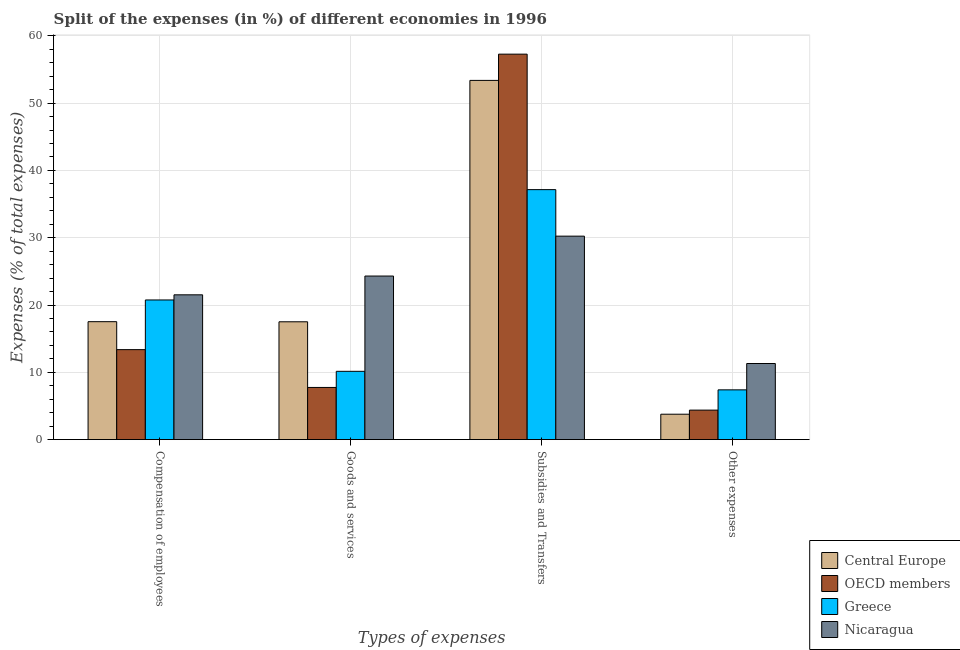How many different coloured bars are there?
Make the answer very short. 4. Are the number of bars on each tick of the X-axis equal?
Offer a terse response. Yes. How many bars are there on the 2nd tick from the left?
Offer a very short reply. 4. How many bars are there on the 3rd tick from the right?
Provide a short and direct response. 4. What is the label of the 4th group of bars from the left?
Your answer should be very brief. Other expenses. What is the percentage of amount spent on compensation of employees in OECD members?
Provide a succinct answer. 13.37. Across all countries, what is the maximum percentage of amount spent on compensation of employees?
Your answer should be compact. 21.51. Across all countries, what is the minimum percentage of amount spent on other expenses?
Your answer should be very brief. 3.77. In which country was the percentage of amount spent on goods and services maximum?
Offer a very short reply. Nicaragua. In which country was the percentage of amount spent on goods and services minimum?
Make the answer very short. OECD members. What is the total percentage of amount spent on other expenses in the graph?
Keep it short and to the point. 26.86. What is the difference between the percentage of amount spent on subsidies in Nicaragua and that in Central Europe?
Offer a very short reply. -23.14. What is the difference between the percentage of amount spent on subsidies in Nicaragua and the percentage of amount spent on compensation of employees in OECD members?
Provide a succinct answer. 16.87. What is the average percentage of amount spent on subsidies per country?
Make the answer very short. 44.51. What is the difference between the percentage of amount spent on other expenses and percentage of amount spent on goods and services in Greece?
Offer a very short reply. -2.75. In how many countries, is the percentage of amount spent on subsidies greater than 38 %?
Ensure brevity in your answer.  2. What is the ratio of the percentage of amount spent on subsidies in OECD members to that in Greece?
Keep it short and to the point. 1.54. What is the difference between the highest and the second highest percentage of amount spent on compensation of employees?
Give a very brief answer. 0.76. What is the difference between the highest and the lowest percentage of amount spent on goods and services?
Offer a terse response. 16.55. In how many countries, is the percentage of amount spent on goods and services greater than the average percentage of amount spent on goods and services taken over all countries?
Your answer should be very brief. 2. Is the sum of the percentage of amount spent on other expenses in OECD members and Nicaragua greater than the maximum percentage of amount spent on goods and services across all countries?
Offer a very short reply. No. What does the 3rd bar from the right in Compensation of employees represents?
Provide a short and direct response. OECD members. How many bars are there?
Ensure brevity in your answer.  16. Are all the bars in the graph horizontal?
Give a very brief answer. No. How many countries are there in the graph?
Offer a very short reply. 4. What is the difference between two consecutive major ticks on the Y-axis?
Your response must be concise. 10. Are the values on the major ticks of Y-axis written in scientific E-notation?
Your answer should be very brief. No. Does the graph contain grids?
Provide a succinct answer. Yes. Where does the legend appear in the graph?
Ensure brevity in your answer.  Bottom right. How are the legend labels stacked?
Your answer should be compact. Vertical. What is the title of the graph?
Offer a terse response. Split of the expenses (in %) of different economies in 1996. Does "Palau" appear as one of the legend labels in the graph?
Provide a short and direct response. No. What is the label or title of the X-axis?
Provide a short and direct response. Types of expenses. What is the label or title of the Y-axis?
Give a very brief answer. Expenses (% of total expenses). What is the Expenses (% of total expenses) of Central Europe in Compensation of employees?
Your response must be concise. 17.52. What is the Expenses (% of total expenses) of OECD members in Compensation of employees?
Give a very brief answer. 13.37. What is the Expenses (% of total expenses) in Greece in Compensation of employees?
Keep it short and to the point. 20.75. What is the Expenses (% of total expenses) of Nicaragua in Compensation of employees?
Give a very brief answer. 21.51. What is the Expenses (% of total expenses) in Central Europe in Goods and services?
Your answer should be very brief. 17.51. What is the Expenses (% of total expenses) of OECD members in Goods and services?
Offer a very short reply. 7.75. What is the Expenses (% of total expenses) of Greece in Goods and services?
Offer a terse response. 10.15. What is the Expenses (% of total expenses) of Nicaragua in Goods and services?
Provide a succinct answer. 24.31. What is the Expenses (% of total expenses) in Central Europe in Subsidies and Transfers?
Your response must be concise. 53.38. What is the Expenses (% of total expenses) of OECD members in Subsidies and Transfers?
Provide a succinct answer. 57.28. What is the Expenses (% of total expenses) of Greece in Subsidies and Transfers?
Give a very brief answer. 37.15. What is the Expenses (% of total expenses) of Nicaragua in Subsidies and Transfers?
Provide a succinct answer. 30.23. What is the Expenses (% of total expenses) of Central Europe in Other expenses?
Your answer should be compact. 3.77. What is the Expenses (% of total expenses) in OECD members in Other expenses?
Your response must be concise. 4.38. What is the Expenses (% of total expenses) of Greece in Other expenses?
Make the answer very short. 7.39. What is the Expenses (% of total expenses) in Nicaragua in Other expenses?
Provide a succinct answer. 11.31. Across all Types of expenses, what is the maximum Expenses (% of total expenses) in Central Europe?
Keep it short and to the point. 53.38. Across all Types of expenses, what is the maximum Expenses (% of total expenses) in OECD members?
Offer a very short reply. 57.28. Across all Types of expenses, what is the maximum Expenses (% of total expenses) of Greece?
Give a very brief answer. 37.15. Across all Types of expenses, what is the maximum Expenses (% of total expenses) in Nicaragua?
Provide a succinct answer. 30.23. Across all Types of expenses, what is the minimum Expenses (% of total expenses) in Central Europe?
Make the answer very short. 3.77. Across all Types of expenses, what is the minimum Expenses (% of total expenses) in OECD members?
Offer a terse response. 4.38. Across all Types of expenses, what is the minimum Expenses (% of total expenses) in Greece?
Your answer should be very brief. 7.39. Across all Types of expenses, what is the minimum Expenses (% of total expenses) of Nicaragua?
Offer a terse response. 11.31. What is the total Expenses (% of total expenses) of Central Europe in the graph?
Provide a short and direct response. 92.18. What is the total Expenses (% of total expenses) of OECD members in the graph?
Ensure brevity in your answer.  82.78. What is the total Expenses (% of total expenses) in Greece in the graph?
Offer a very short reply. 75.44. What is the total Expenses (% of total expenses) of Nicaragua in the graph?
Give a very brief answer. 87.36. What is the difference between the Expenses (% of total expenses) of Central Europe in Compensation of employees and that in Goods and services?
Make the answer very short. 0.02. What is the difference between the Expenses (% of total expenses) in OECD members in Compensation of employees and that in Goods and services?
Provide a succinct answer. 5.62. What is the difference between the Expenses (% of total expenses) in Greece in Compensation of employees and that in Goods and services?
Your answer should be compact. 10.6. What is the difference between the Expenses (% of total expenses) in Nicaragua in Compensation of employees and that in Goods and services?
Give a very brief answer. -2.79. What is the difference between the Expenses (% of total expenses) in Central Europe in Compensation of employees and that in Subsidies and Transfers?
Make the answer very short. -35.85. What is the difference between the Expenses (% of total expenses) in OECD members in Compensation of employees and that in Subsidies and Transfers?
Offer a very short reply. -43.91. What is the difference between the Expenses (% of total expenses) in Greece in Compensation of employees and that in Subsidies and Transfers?
Your response must be concise. -16.39. What is the difference between the Expenses (% of total expenses) in Nicaragua in Compensation of employees and that in Subsidies and Transfers?
Your answer should be compact. -8.72. What is the difference between the Expenses (% of total expenses) in Central Europe in Compensation of employees and that in Other expenses?
Make the answer very short. 13.75. What is the difference between the Expenses (% of total expenses) in OECD members in Compensation of employees and that in Other expenses?
Offer a very short reply. 8.99. What is the difference between the Expenses (% of total expenses) of Greece in Compensation of employees and that in Other expenses?
Your answer should be very brief. 13.36. What is the difference between the Expenses (% of total expenses) of Nicaragua in Compensation of employees and that in Other expenses?
Ensure brevity in your answer.  10.21. What is the difference between the Expenses (% of total expenses) of Central Europe in Goods and services and that in Subsidies and Transfers?
Provide a succinct answer. -35.87. What is the difference between the Expenses (% of total expenses) of OECD members in Goods and services and that in Subsidies and Transfers?
Your response must be concise. -49.53. What is the difference between the Expenses (% of total expenses) of Greece in Goods and services and that in Subsidies and Transfers?
Keep it short and to the point. -27. What is the difference between the Expenses (% of total expenses) in Nicaragua in Goods and services and that in Subsidies and Transfers?
Offer a very short reply. -5.93. What is the difference between the Expenses (% of total expenses) of Central Europe in Goods and services and that in Other expenses?
Your response must be concise. 13.73. What is the difference between the Expenses (% of total expenses) of OECD members in Goods and services and that in Other expenses?
Make the answer very short. 3.37. What is the difference between the Expenses (% of total expenses) of Greece in Goods and services and that in Other expenses?
Your answer should be compact. 2.75. What is the difference between the Expenses (% of total expenses) in Nicaragua in Goods and services and that in Other expenses?
Provide a short and direct response. 13. What is the difference between the Expenses (% of total expenses) of Central Europe in Subsidies and Transfers and that in Other expenses?
Give a very brief answer. 49.61. What is the difference between the Expenses (% of total expenses) in OECD members in Subsidies and Transfers and that in Other expenses?
Make the answer very short. 52.9. What is the difference between the Expenses (% of total expenses) in Greece in Subsidies and Transfers and that in Other expenses?
Your response must be concise. 29.75. What is the difference between the Expenses (% of total expenses) in Nicaragua in Subsidies and Transfers and that in Other expenses?
Provide a succinct answer. 18.93. What is the difference between the Expenses (% of total expenses) in Central Europe in Compensation of employees and the Expenses (% of total expenses) in OECD members in Goods and services?
Provide a short and direct response. 9.77. What is the difference between the Expenses (% of total expenses) of Central Europe in Compensation of employees and the Expenses (% of total expenses) of Greece in Goods and services?
Provide a short and direct response. 7.38. What is the difference between the Expenses (% of total expenses) in Central Europe in Compensation of employees and the Expenses (% of total expenses) in Nicaragua in Goods and services?
Make the answer very short. -6.78. What is the difference between the Expenses (% of total expenses) in OECD members in Compensation of employees and the Expenses (% of total expenses) in Greece in Goods and services?
Keep it short and to the point. 3.22. What is the difference between the Expenses (% of total expenses) in OECD members in Compensation of employees and the Expenses (% of total expenses) in Nicaragua in Goods and services?
Offer a very short reply. -10.94. What is the difference between the Expenses (% of total expenses) of Greece in Compensation of employees and the Expenses (% of total expenses) of Nicaragua in Goods and services?
Your response must be concise. -3.55. What is the difference between the Expenses (% of total expenses) of Central Europe in Compensation of employees and the Expenses (% of total expenses) of OECD members in Subsidies and Transfers?
Provide a short and direct response. -39.75. What is the difference between the Expenses (% of total expenses) of Central Europe in Compensation of employees and the Expenses (% of total expenses) of Greece in Subsidies and Transfers?
Keep it short and to the point. -19.62. What is the difference between the Expenses (% of total expenses) of Central Europe in Compensation of employees and the Expenses (% of total expenses) of Nicaragua in Subsidies and Transfers?
Your response must be concise. -12.71. What is the difference between the Expenses (% of total expenses) in OECD members in Compensation of employees and the Expenses (% of total expenses) in Greece in Subsidies and Transfers?
Give a very brief answer. -23.78. What is the difference between the Expenses (% of total expenses) of OECD members in Compensation of employees and the Expenses (% of total expenses) of Nicaragua in Subsidies and Transfers?
Your answer should be very brief. -16.87. What is the difference between the Expenses (% of total expenses) of Greece in Compensation of employees and the Expenses (% of total expenses) of Nicaragua in Subsidies and Transfers?
Give a very brief answer. -9.48. What is the difference between the Expenses (% of total expenses) of Central Europe in Compensation of employees and the Expenses (% of total expenses) of OECD members in Other expenses?
Keep it short and to the point. 13.14. What is the difference between the Expenses (% of total expenses) in Central Europe in Compensation of employees and the Expenses (% of total expenses) in Greece in Other expenses?
Your answer should be compact. 10.13. What is the difference between the Expenses (% of total expenses) of Central Europe in Compensation of employees and the Expenses (% of total expenses) of Nicaragua in Other expenses?
Ensure brevity in your answer.  6.22. What is the difference between the Expenses (% of total expenses) of OECD members in Compensation of employees and the Expenses (% of total expenses) of Greece in Other expenses?
Your response must be concise. 5.98. What is the difference between the Expenses (% of total expenses) of OECD members in Compensation of employees and the Expenses (% of total expenses) of Nicaragua in Other expenses?
Your answer should be compact. 2.06. What is the difference between the Expenses (% of total expenses) in Greece in Compensation of employees and the Expenses (% of total expenses) in Nicaragua in Other expenses?
Your answer should be very brief. 9.44. What is the difference between the Expenses (% of total expenses) of Central Europe in Goods and services and the Expenses (% of total expenses) of OECD members in Subsidies and Transfers?
Make the answer very short. -39.77. What is the difference between the Expenses (% of total expenses) of Central Europe in Goods and services and the Expenses (% of total expenses) of Greece in Subsidies and Transfers?
Keep it short and to the point. -19.64. What is the difference between the Expenses (% of total expenses) in Central Europe in Goods and services and the Expenses (% of total expenses) in Nicaragua in Subsidies and Transfers?
Provide a short and direct response. -12.73. What is the difference between the Expenses (% of total expenses) in OECD members in Goods and services and the Expenses (% of total expenses) in Greece in Subsidies and Transfers?
Make the answer very short. -29.39. What is the difference between the Expenses (% of total expenses) of OECD members in Goods and services and the Expenses (% of total expenses) of Nicaragua in Subsidies and Transfers?
Provide a succinct answer. -22.48. What is the difference between the Expenses (% of total expenses) in Greece in Goods and services and the Expenses (% of total expenses) in Nicaragua in Subsidies and Transfers?
Your answer should be very brief. -20.09. What is the difference between the Expenses (% of total expenses) of Central Europe in Goods and services and the Expenses (% of total expenses) of OECD members in Other expenses?
Ensure brevity in your answer.  13.13. What is the difference between the Expenses (% of total expenses) of Central Europe in Goods and services and the Expenses (% of total expenses) of Greece in Other expenses?
Give a very brief answer. 10.11. What is the difference between the Expenses (% of total expenses) in Central Europe in Goods and services and the Expenses (% of total expenses) in Nicaragua in Other expenses?
Give a very brief answer. 6.2. What is the difference between the Expenses (% of total expenses) in OECD members in Goods and services and the Expenses (% of total expenses) in Greece in Other expenses?
Provide a succinct answer. 0.36. What is the difference between the Expenses (% of total expenses) in OECD members in Goods and services and the Expenses (% of total expenses) in Nicaragua in Other expenses?
Offer a terse response. -3.56. What is the difference between the Expenses (% of total expenses) of Greece in Goods and services and the Expenses (% of total expenses) of Nicaragua in Other expenses?
Offer a very short reply. -1.16. What is the difference between the Expenses (% of total expenses) in Central Europe in Subsidies and Transfers and the Expenses (% of total expenses) in OECD members in Other expenses?
Your answer should be very brief. 49. What is the difference between the Expenses (% of total expenses) in Central Europe in Subsidies and Transfers and the Expenses (% of total expenses) in Greece in Other expenses?
Ensure brevity in your answer.  45.99. What is the difference between the Expenses (% of total expenses) in Central Europe in Subsidies and Transfers and the Expenses (% of total expenses) in Nicaragua in Other expenses?
Your answer should be very brief. 42.07. What is the difference between the Expenses (% of total expenses) in OECD members in Subsidies and Transfers and the Expenses (% of total expenses) in Greece in Other expenses?
Provide a succinct answer. 49.89. What is the difference between the Expenses (% of total expenses) in OECD members in Subsidies and Transfers and the Expenses (% of total expenses) in Nicaragua in Other expenses?
Offer a very short reply. 45.97. What is the difference between the Expenses (% of total expenses) in Greece in Subsidies and Transfers and the Expenses (% of total expenses) in Nicaragua in Other expenses?
Give a very brief answer. 25.84. What is the average Expenses (% of total expenses) in Central Europe per Types of expenses?
Provide a succinct answer. 23.05. What is the average Expenses (% of total expenses) of OECD members per Types of expenses?
Ensure brevity in your answer.  20.7. What is the average Expenses (% of total expenses) of Greece per Types of expenses?
Provide a short and direct response. 18.86. What is the average Expenses (% of total expenses) in Nicaragua per Types of expenses?
Give a very brief answer. 21.84. What is the difference between the Expenses (% of total expenses) in Central Europe and Expenses (% of total expenses) in OECD members in Compensation of employees?
Your response must be concise. 4.16. What is the difference between the Expenses (% of total expenses) in Central Europe and Expenses (% of total expenses) in Greece in Compensation of employees?
Give a very brief answer. -3.23. What is the difference between the Expenses (% of total expenses) in Central Europe and Expenses (% of total expenses) in Nicaragua in Compensation of employees?
Offer a terse response. -3.99. What is the difference between the Expenses (% of total expenses) in OECD members and Expenses (% of total expenses) in Greece in Compensation of employees?
Provide a short and direct response. -7.38. What is the difference between the Expenses (% of total expenses) in OECD members and Expenses (% of total expenses) in Nicaragua in Compensation of employees?
Your response must be concise. -8.15. What is the difference between the Expenses (% of total expenses) in Greece and Expenses (% of total expenses) in Nicaragua in Compensation of employees?
Your response must be concise. -0.76. What is the difference between the Expenses (% of total expenses) of Central Europe and Expenses (% of total expenses) of OECD members in Goods and services?
Provide a succinct answer. 9.76. What is the difference between the Expenses (% of total expenses) of Central Europe and Expenses (% of total expenses) of Greece in Goods and services?
Offer a terse response. 7.36. What is the difference between the Expenses (% of total expenses) of Central Europe and Expenses (% of total expenses) of Nicaragua in Goods and services?
Ensure brevity in your answer.  -6.8. What is the difference between the Expenses (% of total expenses) of OECD members and Expenses (% of total expenses) of Greece in Goods and services?
Keep it short and to the point. -2.4. What is the difference between the Expenses (% of total expenses) of OECD members and Expenses (% of total expenses) of Nicaragua in Goods and services?
Your answer should be very brief. -16.55. What is the difference between the Expenses (% of total expenses) of Greece and Expenses (% of total expenses) of Nicaragua in Goods and services?
Ensure brevity in your answer.  -14.16. What is the difference between the Expenses (% of total expenses) of Central Europe and Expenses (% of total expenses) of OECD members in Subsidies and Transfers?
Offer a terse response. -3.9. What is the difference between the Expenses (% of total expenses) in Central Europe and Expenses (% of total expenses) in Greece in Subsidies and Transfers?
Ensure brevity in your answer.  16.23. What is the difference between the Expenses (% of total expenses) of Central Europe and Expenses (% of total expenses) of Nicaragua in Subsidies and Transfers?
Offer a terse response. 23.14. What is the difference between the Expenses (% of total expenses) in OECD members and Expenses (% of total expenses) in Greece in Subsidies and Transfers?
Offer a very short reply. 20.13. What is the difference between the Expenses (% of total expenses) of OECD members and Expenses (% of total expenses) of Nicaragua in Subsidies and Transfers?
Offer a very short reply. 27.04. What is the difference between the Expenses (% of total expenses) of Greece and Expenses (% of total expenses) of Nicaragua in Subsidies and Transfers?
Offer a terse response. 6.91. What is the difference between the Expenses (% of total expenses) in Central Europe and Expenses (% of total expenses) in OECD members in Other expenses?
Make the answer very short. -0.61. What is the difference between the Expenses (% of total expenses) in Central Europe and Expenses (% of total expenses) in Greece in Other expenses?
Your response must be concise. -3.62. What is the difference between the Expenses (% of total expenses) of Central Europe and Expenses (% of total expenses) of Nicaragua in Other expenses?
Provide a short and direct response. -7.54. What is the difference between the Expenses (% of total expenses) in OECD members and Expenses (% of total expenses) in Greece in Other expenses?
Make the answer very short. -3.01. What is the difference between the Expenses (% of total expenses) in OECD members and Expenses (% of total expenses) in Nicaragua in Other expenses?
Your answer should be compact. -6.93. What is the difference between the Expenses (% of total expenses) in Greece and Expenses (% of total expenses) in Nicaragua in Other expenses?
Your answer should be compact. -3.91. What is the ratio of the Expenses (% of total expenses) of OECD members in Compensation of employees to that in Goods and services?
Offer a terse response. 1.72. What is the ratio of the Expenses (% of total expenses) in Greece in Compensation of employees to that in Goods and services?
Your answer should be very brief. 2.04. What is the ratio of the Expenses (% of total expenses) of Nicaragua in Compensation of employees to that in Goods and services?
Your response must be concise. 0.89. What is the ratio of the Expenses (% of total expenses) of Central Europe in Compensation of employees to that in Subsidies and Transfers?
Offer a very short reply. 0.33. What is the ratio of the Expenses (% of total expenses) of OECD members in Compensation of employees to that in Subsidies and Transfers?
Your answer should be very brief. 0.23. What is the ratio of the Expenses (% of total expenses) of Greece in Compensation of employees to that in Subsidies and Transfers?
Your answer should be very brief. 0.56. What is the ratio of the Expenses (% of total expenses) in Nicaragua in Compensation of employees to that in Subsidies and Transfers?
Your answer should be compact. 0.71. What is the ratio of the Expenses (% of total expenses) of Central Europe in Compensation of employees to that in Other expenses?
Your answer should be very brief. 4.64. What is the ratio of the Expenses (% of total expenses) of OECD members in Compensation of employees to that in Other expenses?
Offer a very short reply. 3.05. What is the ratio of the Expenses (% of total expenses) in Greece in Compensation of employees to that in Other expenses?
Your answer should be compact. 2.81. What is the ratio of the Expenses (% of total expenses) in Nicaragua in Compensation of employees to that in Other expenses?
Ensure brevity in your answer.  1.9. What is the ratio of the Expenses (% of total expenses) of Central Europe in Goods and services to that in Subsidies and Transfers?
Give a very brief answer. 0.33. What is the ratio of the Expenses (% of total expenses) in OECD members in Goods and services to that in Subsidies and Transfers?
Give a very brief answer. 0.14. What is the ratio of the Expenses (% of total expenses) of Greece in Goods and services to that in Subsidies and Transfers?
Provide a succinct answer. 0.27. What is the ratio of the Expenses (% of total expenses) in Nicaragua in Goods and services to that in Subsidies and Transfers?
Give a very brief answer. 0.8. What is the ratio of the Expenses (% of total expenses) of Central Europe in Goods and services to that in Other expenses?
Keep it short and to the point. 4.64. What is the ratio of the Expenses (% of total expenses) of OECD members in Goods and services to that in Other expenses?
Ensure brevity in your answer.  1.77. What is the ratio of the Expenses (% of total expenses) of Greece in Goods and services to that in Other expenses?
Give a very brief answer. 1.37. What is the ratio of the Expenses (% of total expenses) of Nicaragua in Goods and services to that in Other expenses?
Your answer should be very brief. 2.15. What is the ratio of the Expenses (% of total expenses) of Central Europe in Subsidies and Transfers to that in Other expenses?
Make the answer very short. 14.15. What is the ratio of the Expenses (% of total expenses) in OECD members in Subsidies and Transfers to that in Other expenses?
Offer a very short reply. 13.07. What is the ratio of the Expenses (% of total expenses) of Greece in Subsidies and Transfers to that in Other expenses?
Give a very brief answer. 5.02. What is the ratio of the Expenses (% of total expenses) in Nicaragua in Subsidies and Transfers to that in Other expenses?
Give a very brief answer. 2.67. What is the difference between the highest and the second highest Expenses (% of total expenses) of Central Europe?
Provide a succinct answer. 35.85. What is the difference between the highest and the second highest Expenses (% of total expenses) in OECD members?
Keep it short and to the point. 43.91. What is the difference between the highest and the second highest Expenses (% of total expenses) in Greece?
Your answer should be very brief. 16.39. What is the difference between the highest and the second highest Expenses (% of total expenses) in Nicaragua?
Ensure brevity in your answer.  5.93. What is the difference between the highest and the lowest Expenses (% of total expenses) of Central Europe?
Your answer should be very brief. 49.61. What is the difference between the highest and the lowest Expenses (% of total expenses) in OECD members?
Your answer should be compact. 52.9. What is the difference between the highest and the lowest Expenses (% of total expenses) in Greece?
Provide a succinct answer. 29.75. What is the difference between the highest and the lowest Expenses (% of total expenses) in Nicaragua?
Make the answer very short. 18.93. 